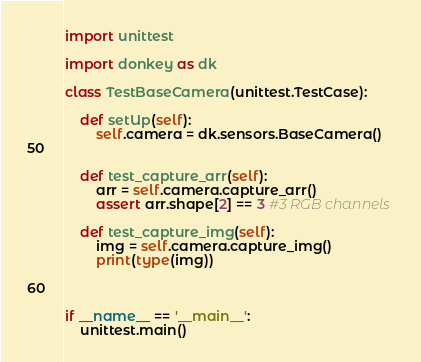<code> <loc_0><loc_0><loc_500><loc_500><_Python_>import unittest

import donkey as dk

class TestBaseCamera(unittest.TestCase):

    def setUp(self):
        self.camera = dk.sensors.BaseCamera()
        

    def test_capture_arr(self):
        arr = self.camera.capture_arr()
        assert arr.shape[2] == 3 #3 RGB channels

    def test_capture_img(self):
        img = self.camera.capture_img()
        print(type(img))



if __name__ == '__main__':
    unittest.main()</code> 